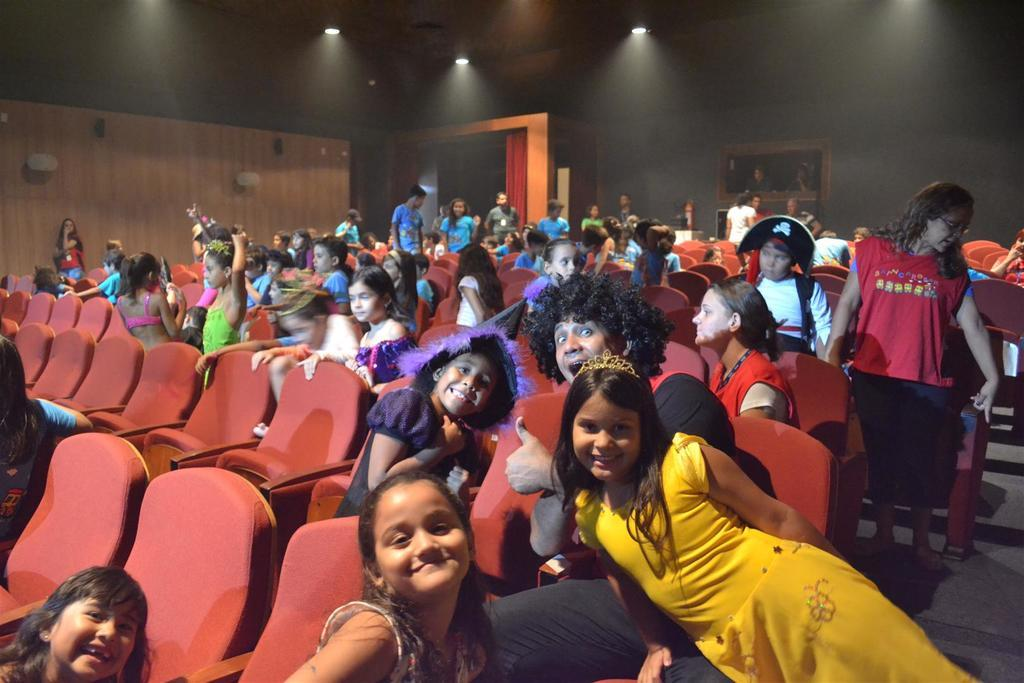What can be seen in the image? There are kids in the image. What is the person in the image doing? There is a person sitting on a chair. How many chairs are visible in the image? There are chairs in the image. What can be seen in the background of the image? There are people standing in the background and a wall with frames on it. What is on the roof top? There are lights on the roof top. What is present in the image that might be used for privacy or decoration? There is a curtain in the image. What architectural features are visible in the image? There are doors in the image. How many cats are sitting on the chairs in the image? There are no cats present in the image. What type of society is depicted in the image? The image does not depict any specific society; it shows a scene with kids, a person sitting on a chair, and other elements. 